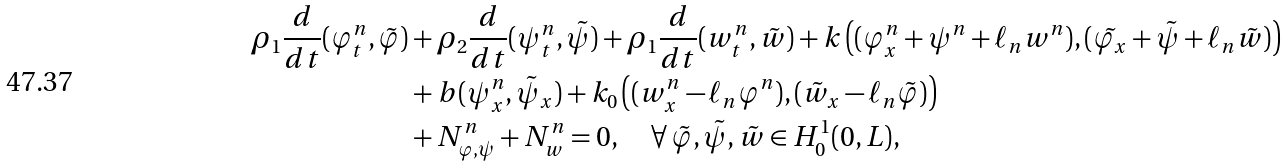Convert formula to latex. <formula><loc_0><loc_0><loc_500><loc_500>\rho _ { 1 } \frac { d } { d t } ( \varphi _ { t } ^ { n } , \tilde { \varphi } ) & + \rho _ { 2 } \frac { d } { d t } ( \psi ^ { n } _ { t } , \tilde { \psi } ) + \rho _ { 1 } \frac { d } { d t } ( w ^ { n } _ { t } , \tilde { w } ) + k \left ( ( \varphi ^ { n } _ { x } + \psi ^ { n } + \ell _ { n } w ^ { n } ) , ( \tilde { \varphi _ { x } } + \tilde { \psi } + \ell _ { n } \tilde { w } ) \right ) \\ & + b ( \psi ^ { n } _ { x } , \tilde { \psi } _ { x } ) + k _ { 0 } \left ( ( w ^ { n } _ { x } - \ell _ { n } \varphi ^ { n } ) , ( \tilde { w } _ { x } - \ell _ { n } \tilde { \varphi } ) \right ) \\ & + N _ { \varphi , \psi } ^ { n } + N _ { w } ^ { n } = 0 , \quad \forall \, \tilde { \varphi } , \tilde { \psi } , \tilde { w } \in H ^ { 1 } _ { 0 } ( 0 , L ) ,</formula> 